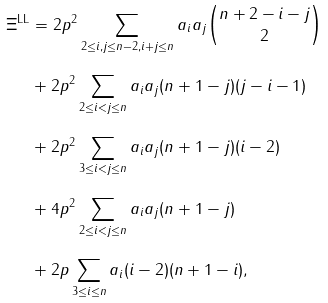Convert formula to latex. <formula><loc_0><loc_0><loc_500><loc_500>\Xi ^ { \text {LL} } & = 2 p ^ { 2 } \sum _ { 2 \leq i , j \leq n - 2 , i + j \leq n } a _ { i } a _ { j } \binom { n + 2 - i - j } { 2 } \\ & + 2 p ^ { 2 } \sum _ { 2 \leq i < j \leq n } a _ { i } a _ { j } ( n + 1 - j ) ( j - i - 1 ) \\ & + 2 p ^ { 2 } \sum _ { 3 \leq i < j \leq n } a _ { i } a _ { j } ( n + 1 - j ) ( i - 2 ) \\ & + 4 p ^ { 2 } \sum _ { 2 \leq i < j \leq n } a _ { i } a _ { j } ( n + 1 - j ) \\ & + 2 p \sum _ { 3 \leq i \leq n } a _ { i } ( i - 2 ) ( n + 1 - i ) ,</formula> 